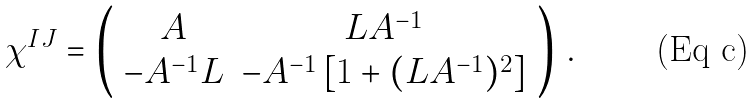<formula> <loc_0><loc_0><loc_500><loc_500>\chi ^ { I J } = \left ( \begin{array} { c c } A & L A ^ { - 1 } \\ - A ^ { - 1 } L & - A ^ { - 1 } \left [ 1 + ( L A ^ { - 1 } ) ^ { 2 } \right ] \end{array} \right ) \, .</formula> 